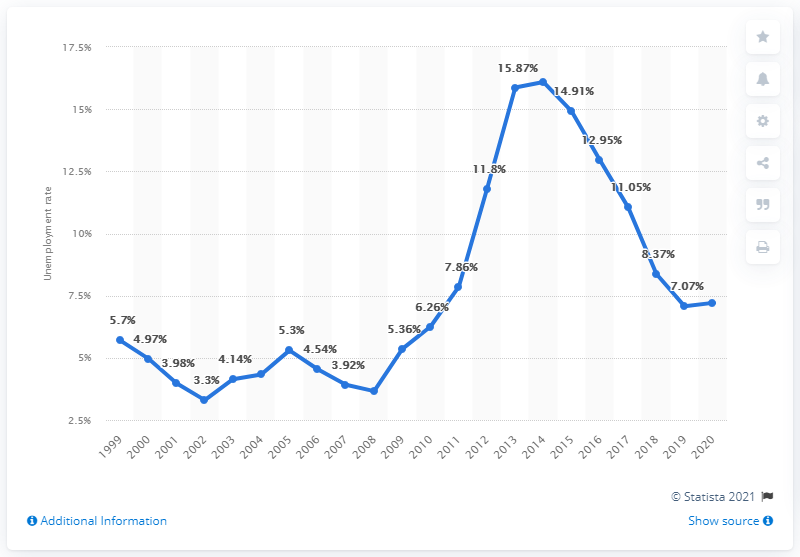Indicate a few pertinent items in this graphic. The unemployment rate in Cyprus in 2020 was 7.21%. 